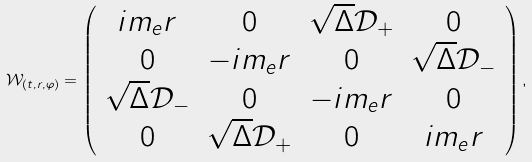<formula> <loc_0><loc_0><loc_500><loc_500>\mathcal { W } _ { ( t , r , \varphi ) } = \left ( \begin{array} { c c c c } i m _ { e } r & 0 & \sqrt { \Delta } \mathcal { D } _ { + } & 0 \\ 0 & - i m _ { e } r & 0 & \sqrt { \Delta } \mathcal { D } _ { - } \\ \sqrt { \Delta } \mathcal { D } _ { - } & 0 & - i m _ { e } r & 0 \\ 0 & \sqrt { \Delta } \mathcal { D } _ { + } & 0 & i m _ { e } r \end{array} \right ) ,</formula> 